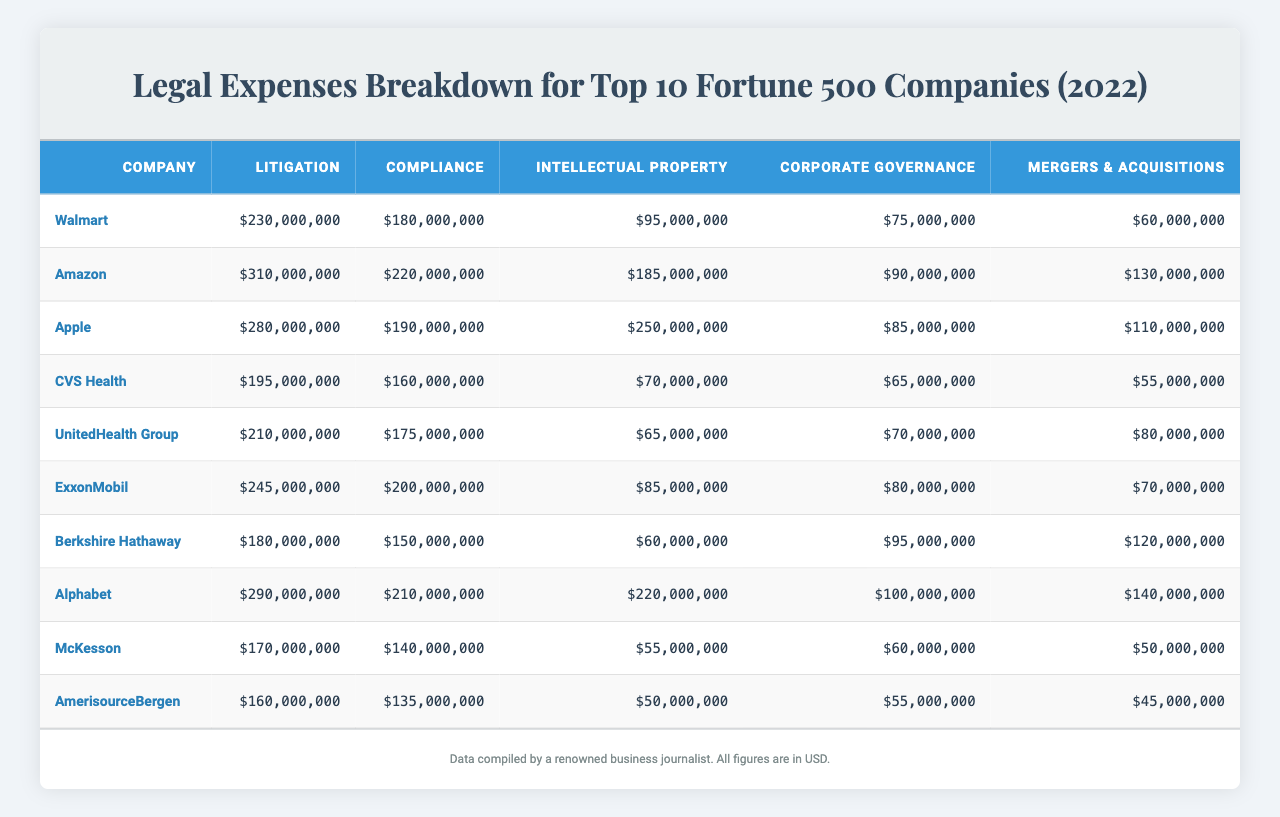What is the total amount spent on litigation by Walmart? Looking at the table, Walmart's litigation expense is listed as $230,000,000
Answer: $230,000,000 Which company had the highest compliance expenses? The table shows that Amazon has the highest compliance expenses at $220,000,000 compared to other companies.
Answer: $220,000,000 What is the difference in intellectual property expenses between Apple and CVS Health? Apple's intellectual property expense is $250,000,000 and CVS Health's is $70,000,000. The difference is calculated as $250,000,000 - $70,000,000 = $180,000,000.
Answer: $180,000,000 How much did Fortune 500 companies spend on mergers and acquisitions in total? Summing up the mergers and acquisitions expenses from all companies: $60M + $130M + $110M + $55M + $80M + $70M + $120M + $140M + $50M + $45M = $1,020,000,000.
Answer: $1,020,000,000 Is ExxonMobil's total legal expenses higher than that of CVS Health? ExxonMobil's total expenses (litigation + compliance + intellectual property + corporate governance + mergers & acquisitions) is $245M + $200M + $85M + $80M + $70M = $680M. CVS Health's total is $195M + $160M + $70M + $65M + $55M = $545M. Since $680M > $545M, ExxonMobil’s total is indeed higher.
Answer: Yes What is the average litigation expense for the top 10 companies? Summing the litigation expenses ($230M + $310M + $280M + $195M + $210M + $245M + $180M + $290M + $170M + $160M) gives us $1,920,000,000. Dividing by 10 gives an average of $192,000,000.
Answer: $192,000,000 Which company spent more on corporate governance, UnitedHealth Group or Alphabet? UnitedHealth Group spent $70M on corporate governance, while Alphabet spent $100M. Since $100M > $70M, Alphabet spent more.
Answer: Alphabet What percentage of Apple’s total legal expenses is spent on compliance? Apple's total legal expenses are $280M + $190M + $250M + $85M + $110M = $915M. The compliance expense is $190M. To find the percentage: ($190M / $915M) * 100 = 20.8%.
Answer: 20.8% Which company had the lowest aggregate legal expenses? By calculating the total expenses for each company, AmerisourceBergen had the lowest with $135M (compliance) + $160M (litigation) + $50M (intellectual property) + $55M (corporate governance) + $45M (mergers and acquisitions) = $445M.
Answer: AmerisourceBergen How does Amazon’s intellectual property expense compare to that of Berkshire Hathaway? Amazon spent $185M on intellectual property while Berkshire Hathaway spent $60M. Subtracting gives us $185M - $60M = $125M, indicating Amazon spent more.
Answer: $125,000,000 